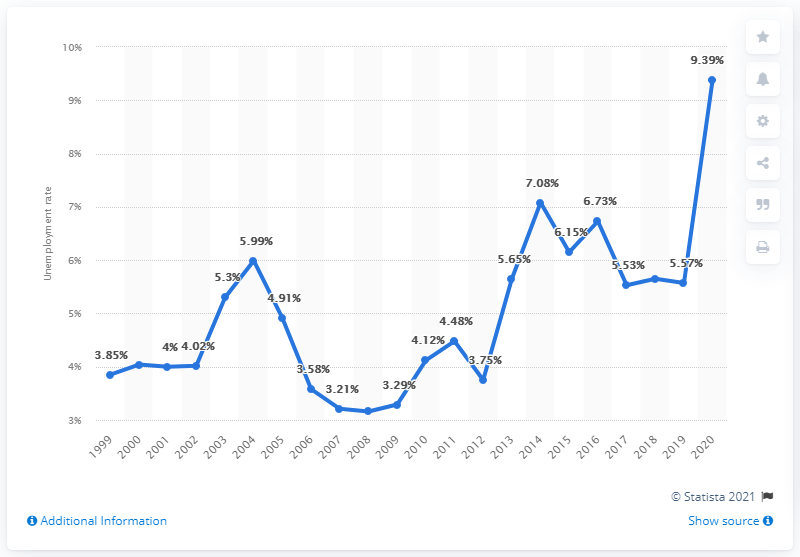Specify some key components in this picture. In 2020, the unemployment rate in Honduras was 9.39%. 